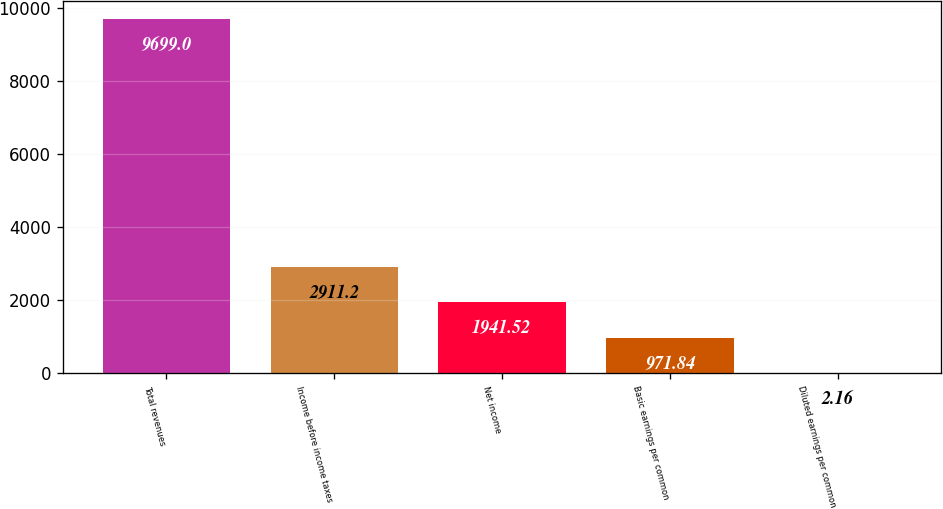Convert chart. <chart><loc_0><loc_0><loc_500><loc_500><bar_chart><fcel>Total revenues<fcel>Income before income taxes<fcel>Net income<fcel>Basic earnings per common<fcel>Diluted earnings per common<nl><fcel>9699<fcel>2911.2<fcel>1941.52<fcel>971.84<fcel>2.16<nl></chart> 